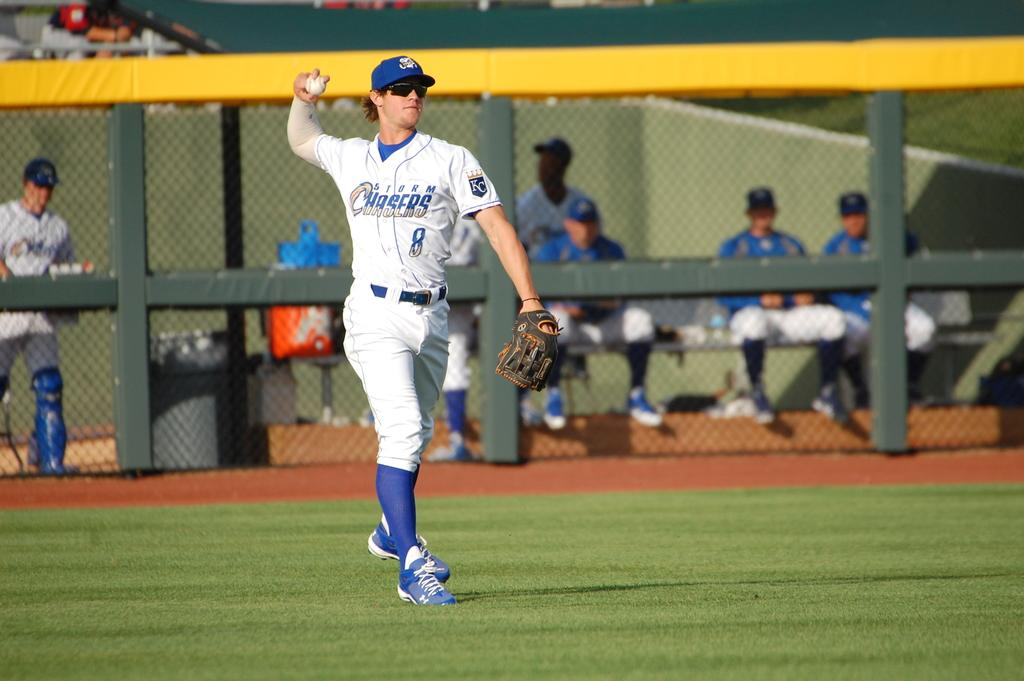<image>
Present a compact description of the photo's key features. The Storm Chasers player is about to throw the ball. 